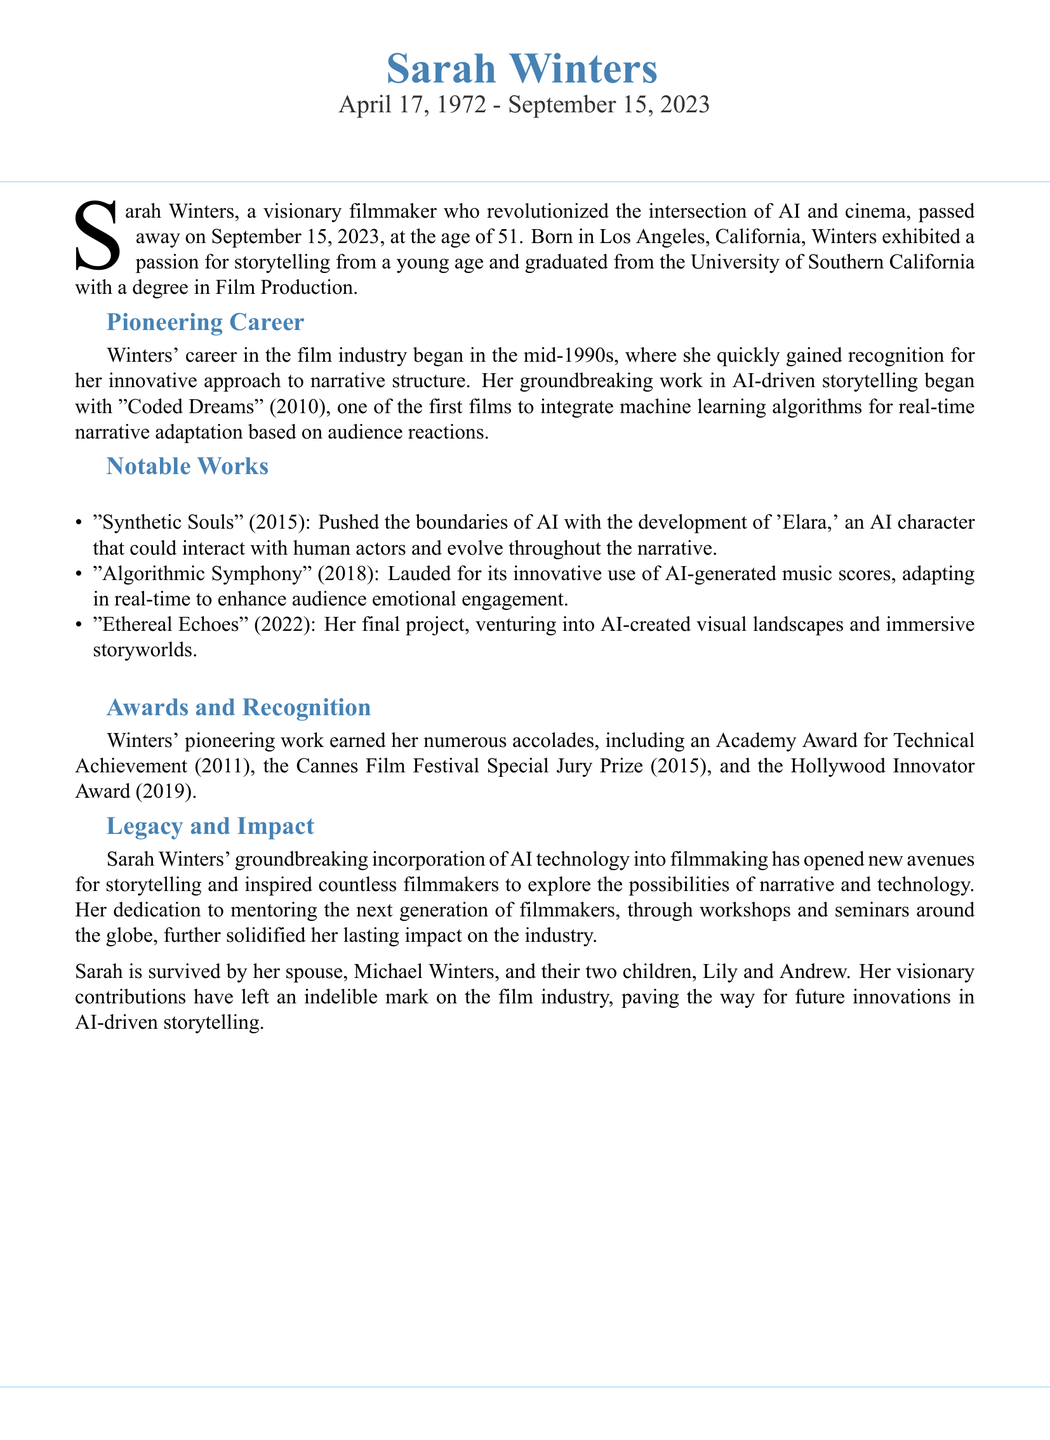What is the full name of the filmmaker? The document states her full name at the beginning as "Sarah Winters."
Answer: Sarah Winters When was Sarah Winters born? The document provides her birth date, which is noted as April 17, 1972.
Answer: April 17, 1972 What is the title of her first film that integrated AI? The document lists her first AI-driven film as "Coded Dreams."
Answer: Coded Dreams Which award did she win in 2011? The document mentions that she received an Academy Award for Technical Achievement in 2011.
Answer: Academy Award for Technical Achievement What character did Sarah Winters create in "Synthetic Souls"? The obituary notes that she developed 'Elara,' an AI character in her film.
Answer: 'Elara' How many children did Sarah Winters have? The document states she is survived by her two children, Lily and Andrew.
Answer: Two What significant contribution did Winters make to the film industry? The document explains that her incorporation of AI technology opened new avenues for storytelling.
Answer: New avenues for storytelling What was the last film she worked on before her passing? Her final project listed in the document is "Ethereal Echoes."
Answer: Ethereal Echoes Which festival awarded her the Special Jury Prize in 2015? The document specifies that she won the Cannes Film Festival Special Jury Prize in 2015.
Answer: Cannes Film Festival 